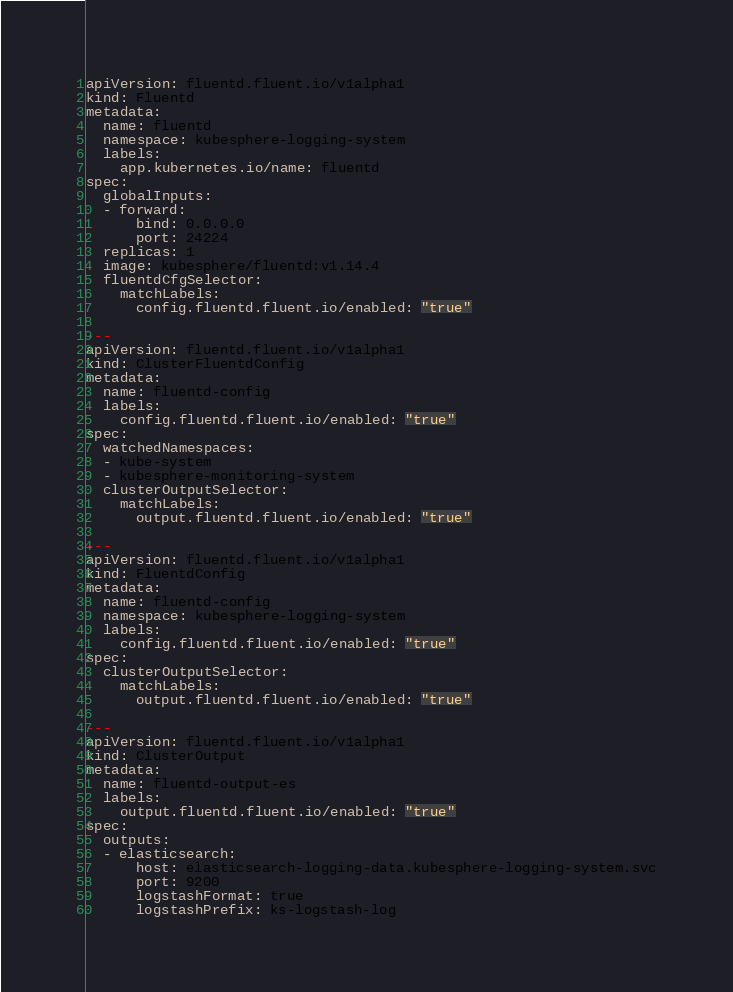<code> <loc_0><loc_0><loc_500><loc_500><_YAML_>apiVersion: fluentd.fluent.io/v1alpha1
kind: Fluentd
metadata:
  name: fluentd
  namespace: kubesphere-logging-system
  labels:
    app.kubernetes.io/name: fluentd
spec:
  globalInputs:
  - forward: 
      bind: 0.0.0.0
      port: 24224
  replicas: 1
  image: kubesphere/fluentd:v1.14.4
  fluentdCfgSelector: 
    matchLabels:
      config.fluentd.fluent.io/enabled: "true"
   
---
apiVersion: fluentd.fluent.io/v1alpha1
kind: ClusterFluentdConfig
metadata:
  name: fluentd-config
  labels:
    config.fluentd.fluent.io/enabled: "true"
spec:
  watchedNamespaces: 
  - kube-system
  - kubesphere-monitoring-system
  clusterOutputSelector:
    matchLabels:
      output.fluentd.fluent.io/enabled: "true"

---
apiVersion: fluentd.fluent.io/v1alpha1
kind: FluentdConfig
metadata:
  name: fluentd-config
  namespace: kubesphere-logging-system
  labels:
    config.fluentd.fluent.io/enabled: "true"
spec:
  clusterOutputSelector:
    matchLabels:
      output.fluentd.fluent.io/enabled: "true"

---
apiVersion: fluentd.fluent.io/v1alpha1
kind: ClusterOutput
metadata:
  name: fluentd-output-es
  labels:
    output.fluentd.fluent.io/enabled: "true"
spec: 
  outputs: 
  - elasticsearch:
      host: elasticsearch-logging-data.kubesphere-logging-system.svc
      port: 9200
      logstashFormat: true
      logstashPrefix: ks-logstash-log
</code> 